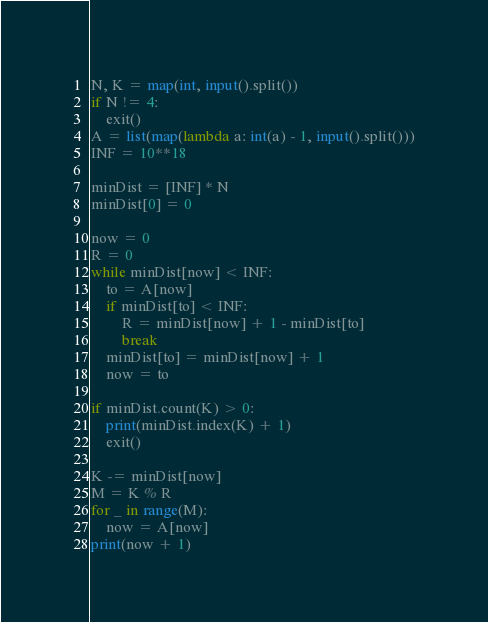<code> <loc_0><loc_0><loc_500><loc_500><_Python_>N, K = map(int, input().split())
if N != 4:
    exit()
A = list(map(lambda a: int(a) - 1, input().split()))
INF = 10**18

minDist = [INF] * N
minDist[0] = 0

now = 0
R = 0
while minDist[now] < INF:
    to = A[now]
    if minDist[to] < INF:
        R = minDist[now] + 1 - minDist[to]
        break
    minDist[to] = minDist[now] + 1
    now = to

if minDist.count(K) > 0:
    print(minDist.index(K) + 1)
    exit()

K -= minDist[now]
M = K % R
for _ in range(M):
    now = A[now]
print(now + 1)</code> 